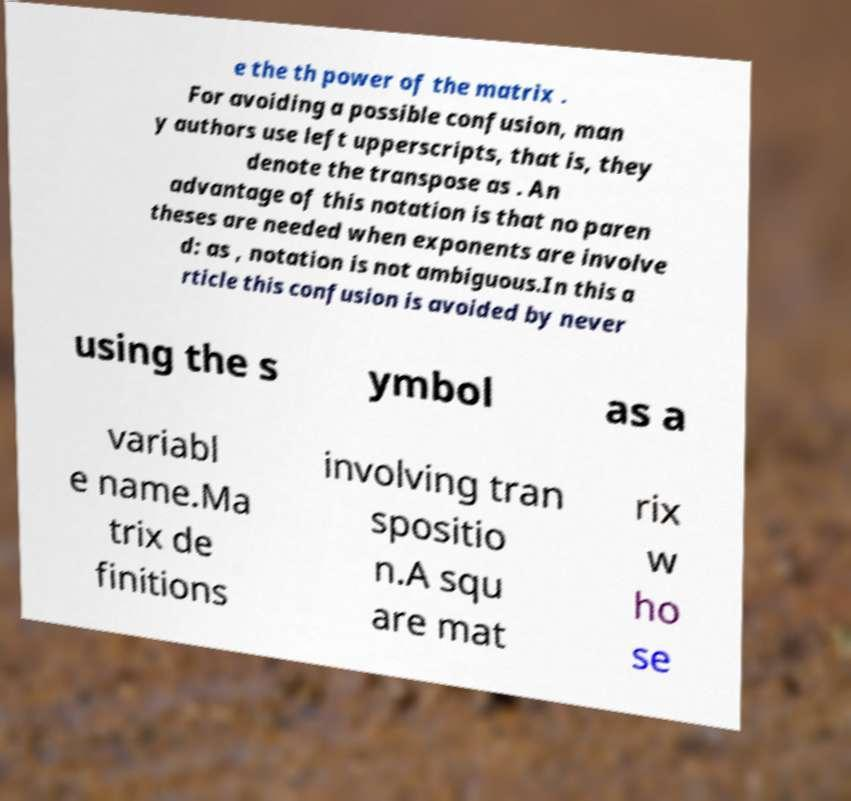There's text embedded in this image that I need extracted. Can you transcribe it verbatim? e the th power of the matrix . For avoiding a possible confusion, man y authors use left upperscripts, that is, they denote the transpose as . An advantage of this notation is that no paren theses are needed when exponents are involve d: as , notation is not ambiguous.In this a rticle this confusion is avoided by never using the s ymbol as a variabl e name.Ma trix de finitions involving tran spositio n.A squ are mat rix w ho se 